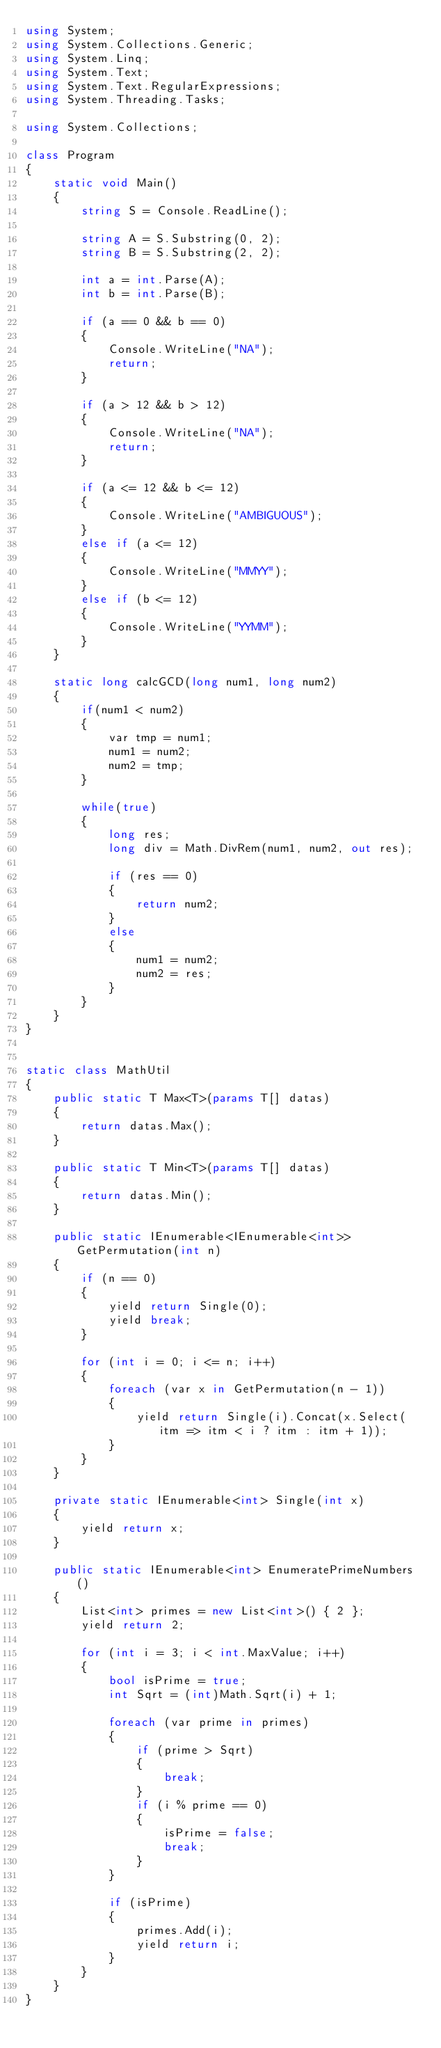Convert code to text. <code><loc_0><loc_0><loc_500><loc_500><_C#_>using System;
using System.Collections.Generic;
using System.Linq;
using System.Text;
using System.Text.RegularExpressions;
using System.Threading.Tasks;

using System.Collections;

class Program
{
    static void Main()
    {
        string S = Console.ReadLine();

        string A = S.Substring(0, 2);
        string B = S.Substring(2, 2);

        int a = int.Parse(A);
        int b = int.Parse(B);

        if (a == 0 && b == 0)
        {
            Console.WriteLine("NA");
            return;
        }

        if (a > 12 && b > 12)
        {
            Console.WriteLine("NA");
            return;
        }

        if (a <= 12 && b <= 12)
        {
            Console.WriteLine("AMBIGUOUS");
        }
        else if (a <= 12)
        {
            Console.WriteLine("MMYY");            
        }
        else if (b <= 12)
        {
            Console.WriteLine("YYMM");
        }
    }

    static long calcGCD(long num1, long num2)
    {
        if(num1 < num2)
        {
            var tmp = num1;
            num1 = num2;
            num2 = tmp;
        }

        while(true)
        {
            long res;
            long div = Math.DivRem(num1, num2, out res);

            if (res == 0)
            {
                return num2;
            }
            else
            {
                num1 = num2;
                num2 = res;
            }
        }
    }
}


static class MathUtil
{
    public static T Max<T>(params T[] datas)
    {
        return datas.Max();
    }

    public static T Min<T>(params T[] datas)
    {
        return datas.Min();
    }

    public static IEnumerable<IEnumerable<int>> GetPermutation(int n)
    {
        if (n == 0)
        {
            yield return Single(0);
            yield break;
        }

        for (int i = 0; i <= n; i++)
        {
            foreach (var x in GetPermutation(n - 1))
            {
                yield return Single(i).Concat(x.Select(itm => itm < i ? itm : itm + 1));
            }
        }
    }

    private static IEnumerable<int> Single(int x)
    {
        yield return x;
    }

    public static IEnumerable<int> EnumeratePrimeNumbers()
    {
        List<int> primes = new List<int>() { 2 };
        yield return 2;

        for (int i = 3; i < int.MaxValue; i++)
        {
            bool isPrime = true;
            int Sqrt = (int)Math.Sqrt(i) + 1;

            foreach (var prime in primes)
            {
                if (prime > Sqrt)
                {
                    break;
                }
                if (i % prime == 0)
                {
                    isPrime = false;
                    break;
                }
            }

            if (isPrime)
            {
                primes.Add(i);
                yield return i;
            }
        }
    }
}


</code> 